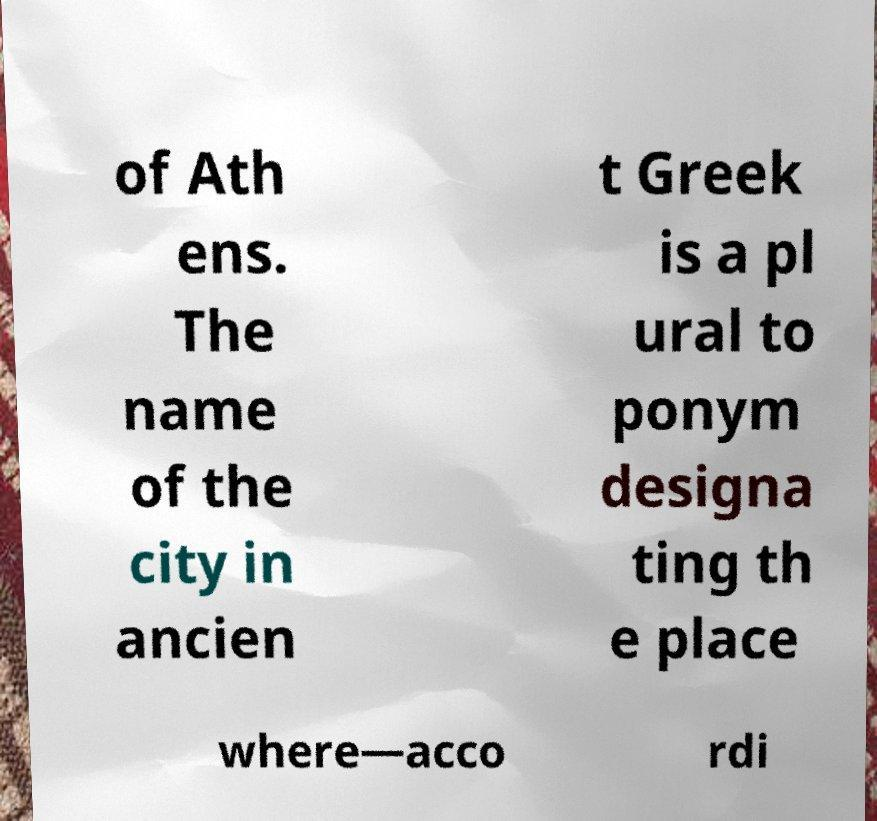Can you read and provide the text displayed in the image?This photo seems to have some interesting text. Can you extract and type it out for me? of Ath ens. The name of the city in ancien t Greek is a pl ural to ponym designa ting th e place where—acco rdi 